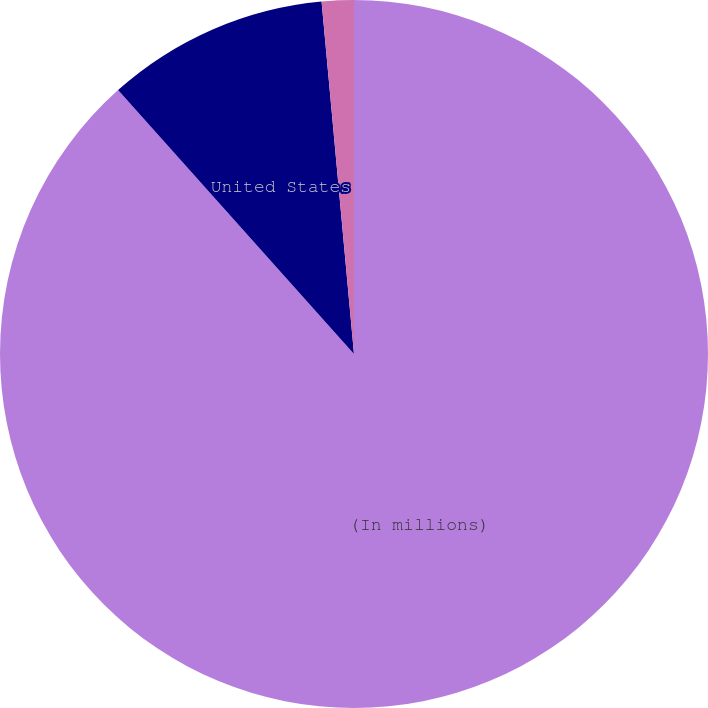<chart> <loc_0><loc_0><loc_500><loc_500><pie_chart><fcel>(In millions)<fcel>United States<fcel>Foreign<nl><fcel>88.38%<fcel>10.15%<fcel>1.46%<nl></chart> 